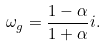Convert formula to latex. <formula><loc_0><loc_0><loc_500><loc_500>\omega _ { g } = \frac { 1 - \alpha } { 1 + \alpha } i .</formula> 